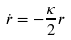<formula> <loc_0><loc_0><loc_500><loc_500>\dot { r } = - \frac { \kappa } { 2 } r</formula> 